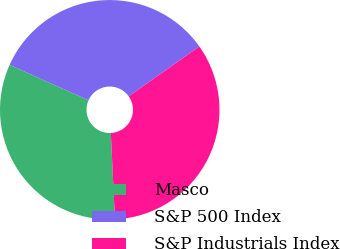<chart> <loc_0><loc_0><loc_500><loc_500><pie_chart><fcel>Masco<fcel>S&P 500 Index<fcel>S&P Industrials Index<nl><fcel>32.46%<fcel>33.49%<fcel>34.04%<nl></chart> 